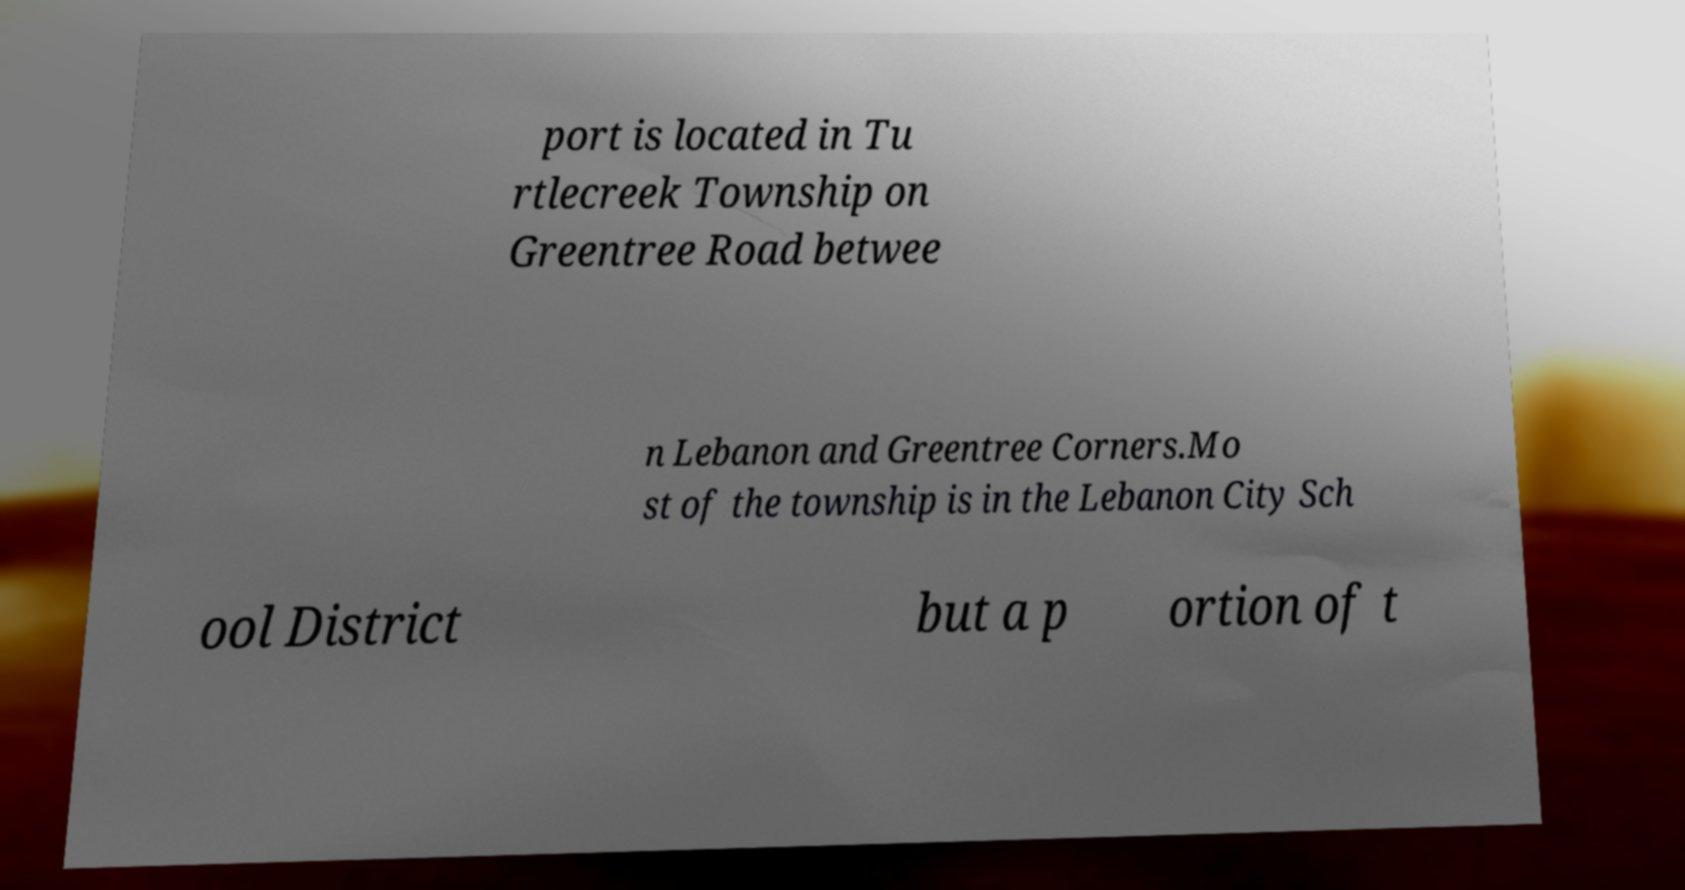Can you accurately transcribe the text from the provided image for me? port is located in Tu rtlecreek Township on Greentree Road betwee n Lebanon and Greentree Corners.Mo st of the township is in the Lebanon City Sch ool District but a p ortion of t 